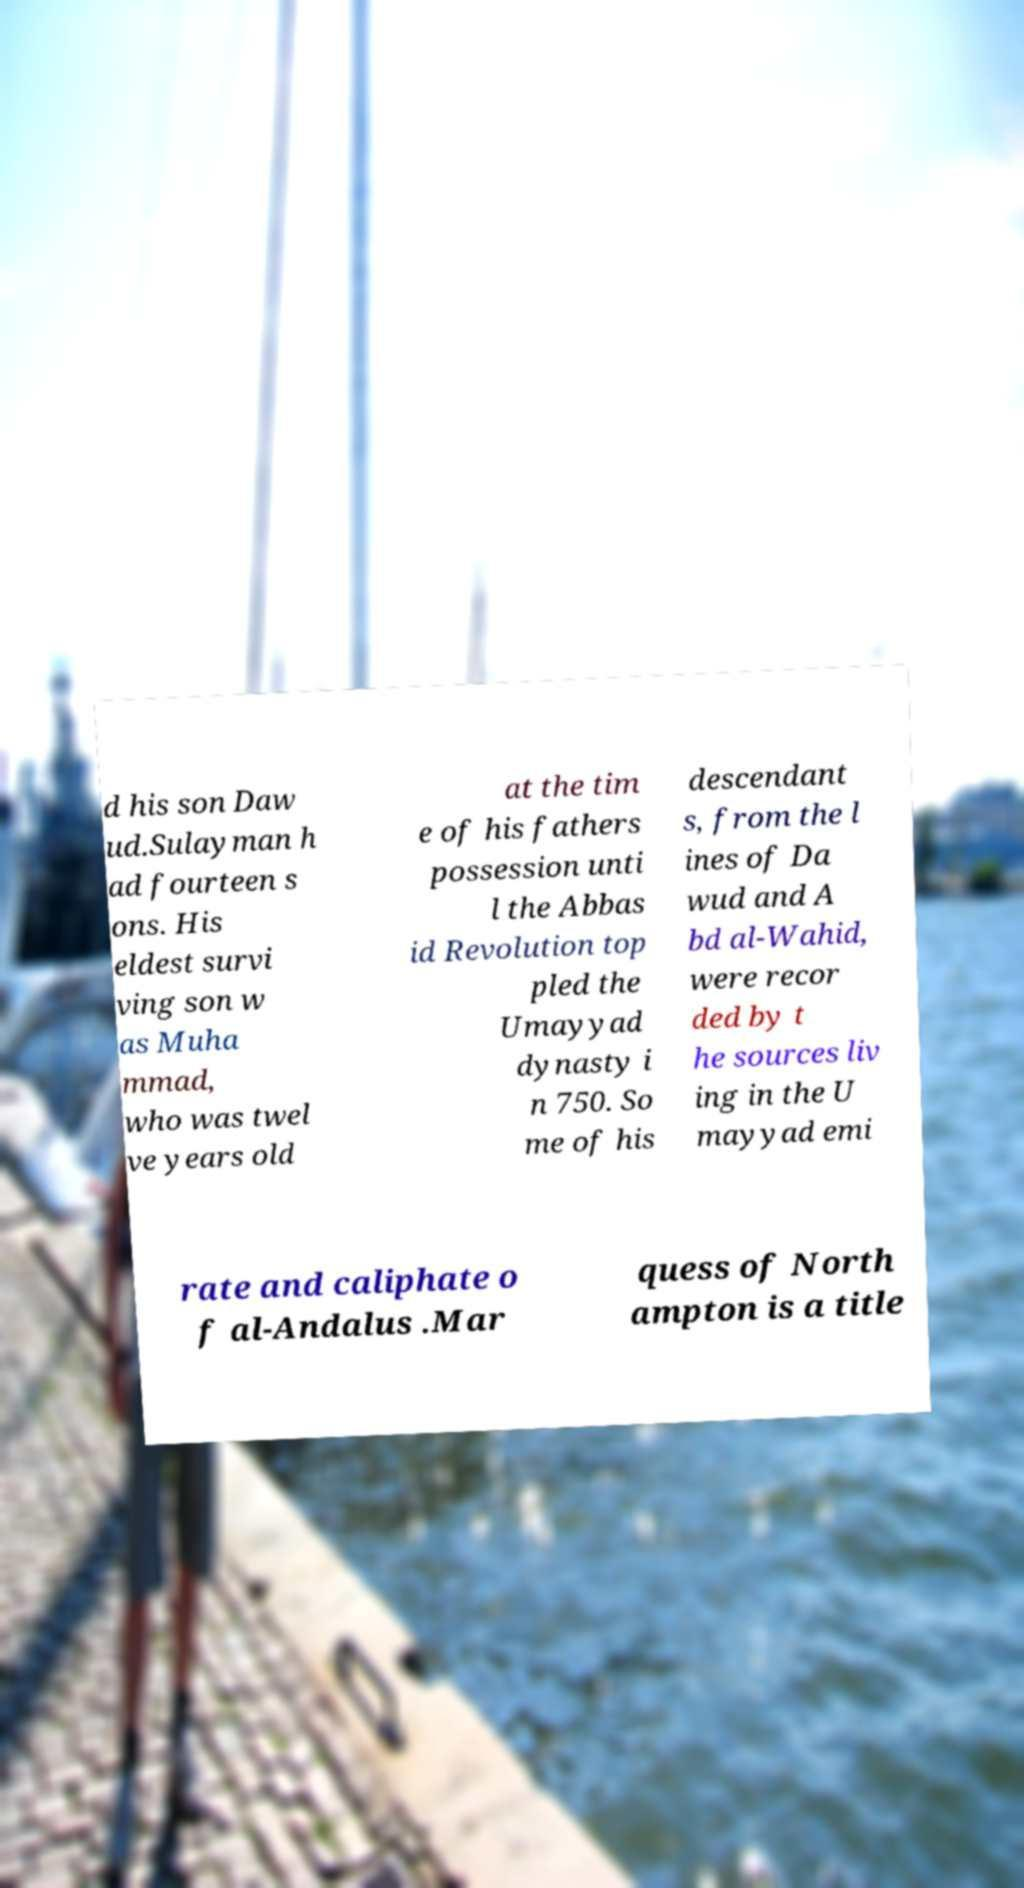Can you read and provide the text displayed in the image?This photo seems to have some interesting text. Can you extract and type it out for me? d his son Daw ud.Sulayman h ad fourteen s ons. His eldest survi ving son w as Muha mmad, who was twel ve years old at the tim e of his fathers possession unti l the Abbas id Revolution top pled the Umayyad dynasty i n 750. So me of his descendant s, from the l ines of Da wud and A bd al-Wahid, were recor ded by t he sources liv ing in the U mayyad emi rate and caliphate o f al-Andalus .Mar quess of North ampton is a title 